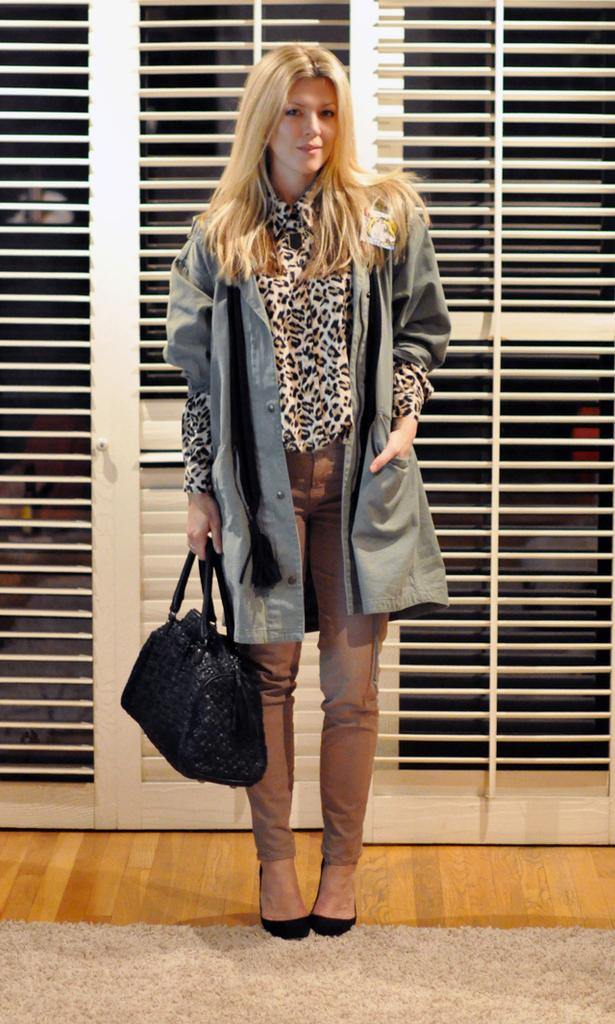Who is present in the image? There is a woman in the image. What is the woman doing in the image? The woman is standing on the floor and holding a bag with her hands. What can be seen in the background of the image? There is a door in the background of the image. What is the surface that the woman is standing on? The floor is visible in the image. How many kittens are playing on the advertisement in the image? There is no advertisement or kittens present in the image. 